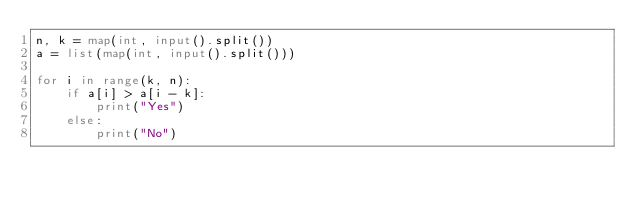<code> <loc_0><loc_0><loc_500><loc_500><_Python_>n, k = map(int, input().split())
a = list(map(int, input().split()))

for i in range(k, n):
    if a[i] > a[i - k]:
        print("Yes")
    else:
        print("No")</code> 